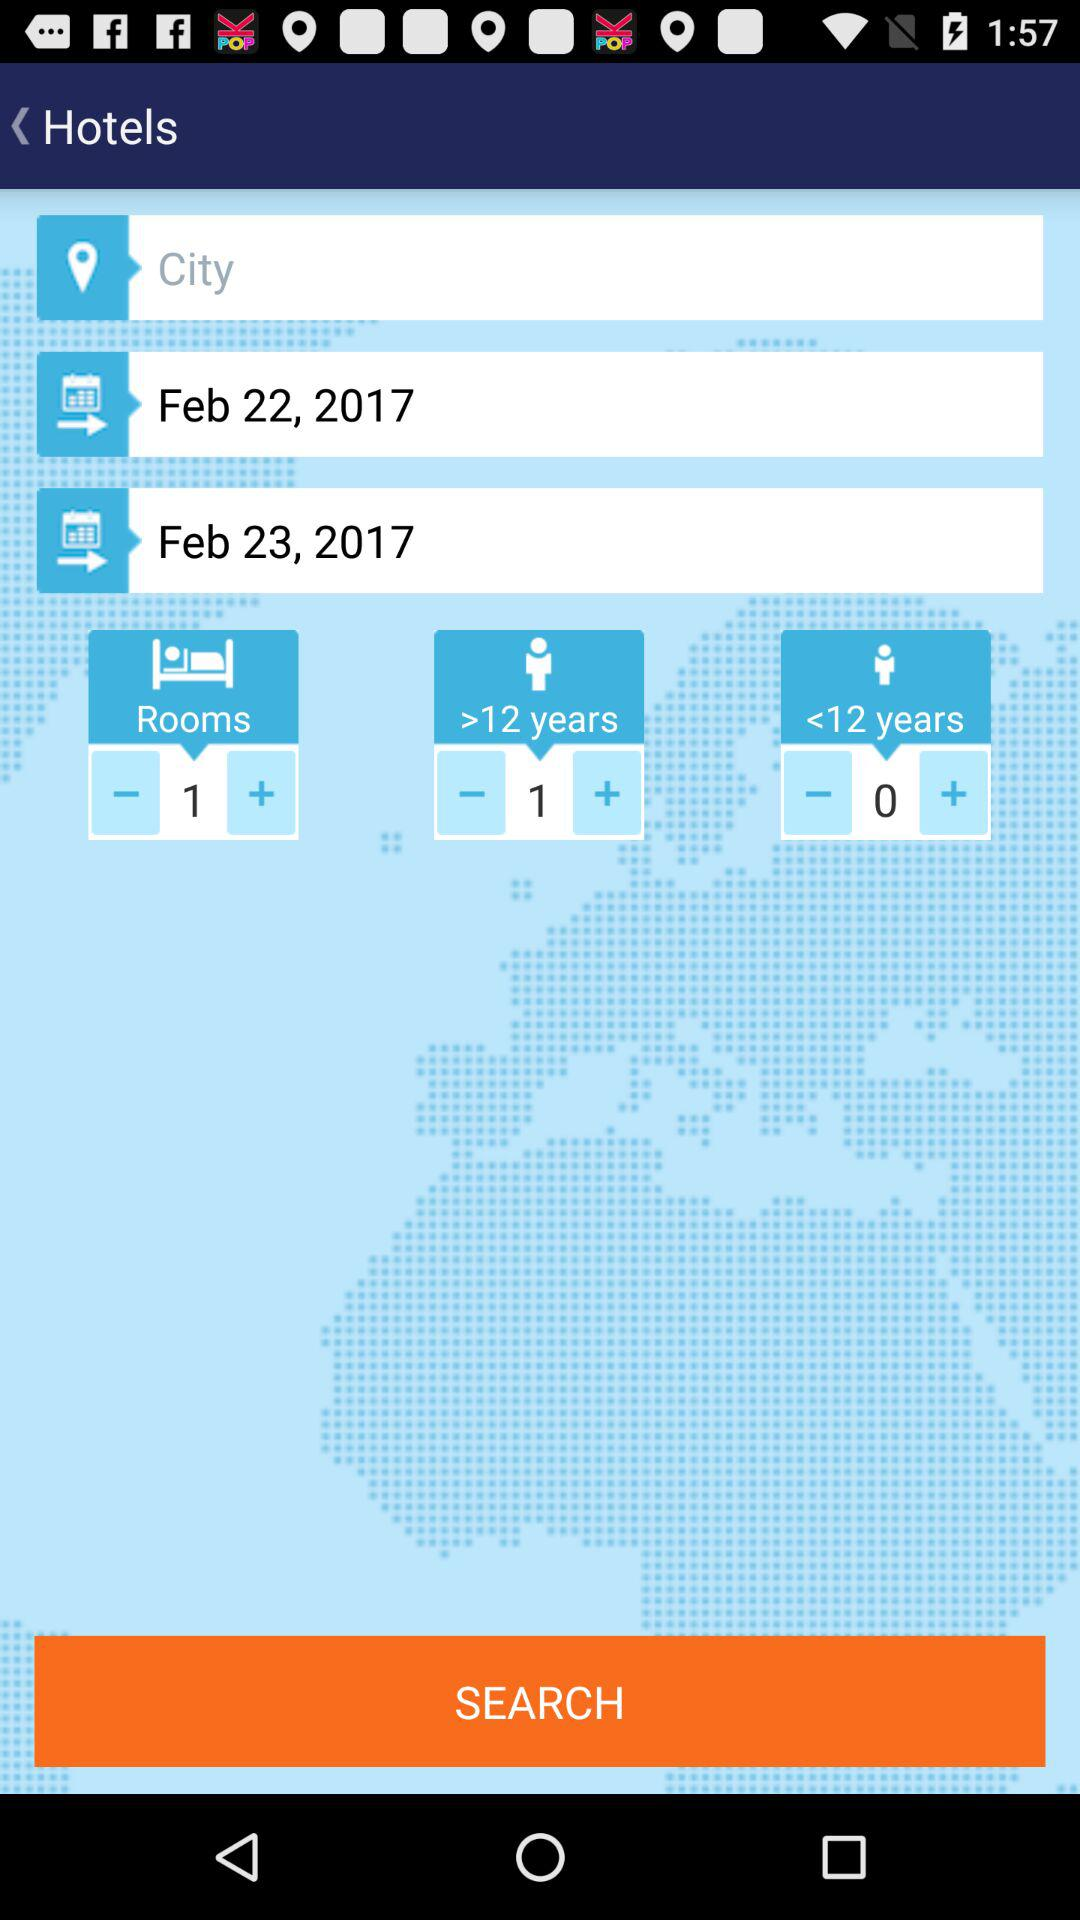What is the number of children over 12 years of age? The number of children over 12 years of age is 1. 